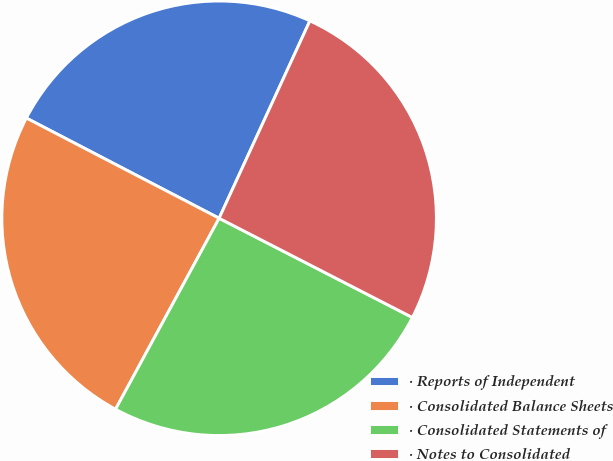<chart> <loc_0><loc_0><loc_500><loc_500><pie_chart><fcel>· Reports of Independent<fcel>· Consolidated Balance Sheets<fcel>· Consolidated Statements of<fcel>· Notes to Consolidated<nl><fcel>24.23%<fcel>24.72%<fcel>25.36%<fcel>25.69%<nl></chart> 